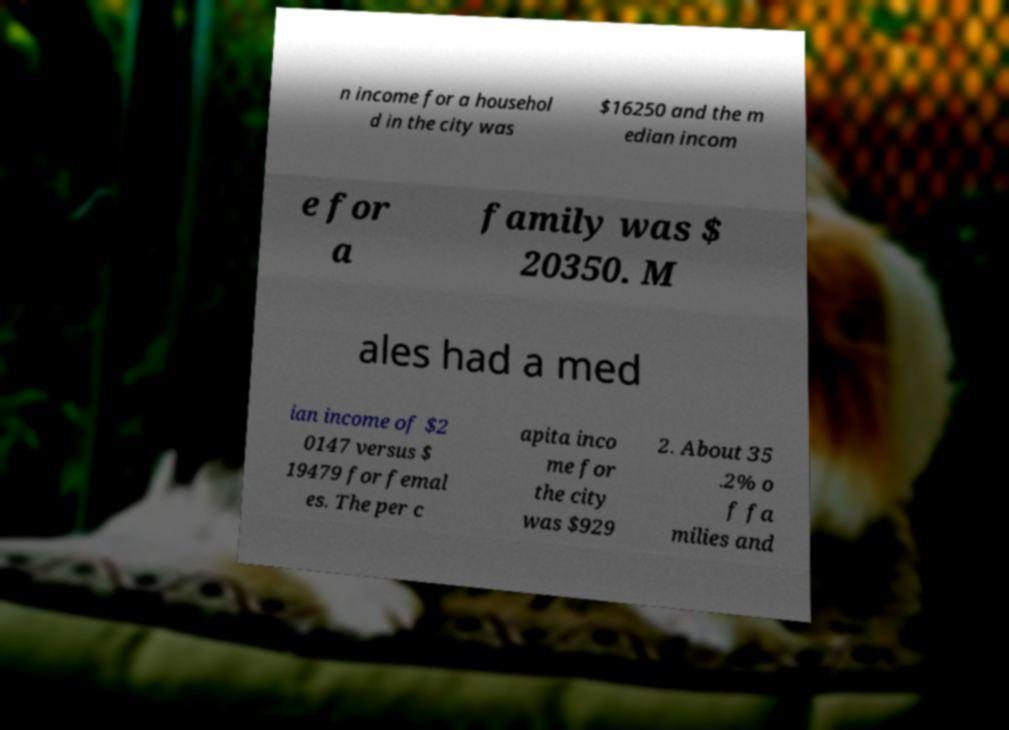Could you assist in decoding the text presented in this image and type it out clearly? n income for a househol d in the city was $16250 and the m edian incom e for a family was $ 20350. M ales had a med ian income of $2 0147 versus $ 19479 for femal es. The per c apita inco me for the city was $929 2. About 35 .2% o f fa milies and 